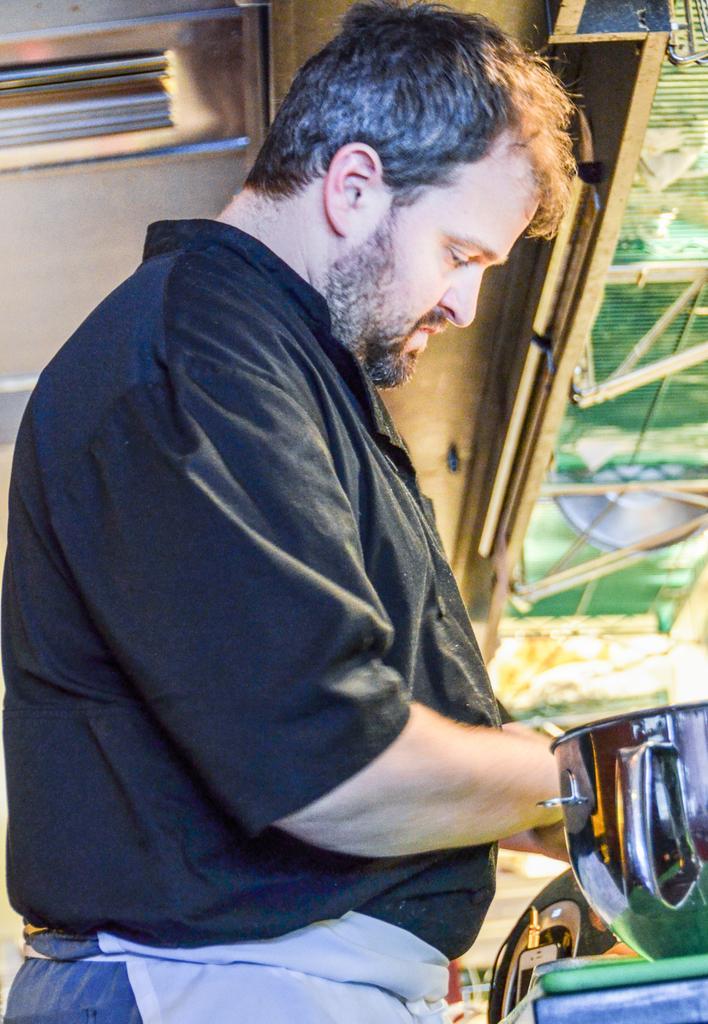Describe this image in one or two sentences. As we can see in the image there is a man wearing black color shirt and in front of him there is a bowl. 